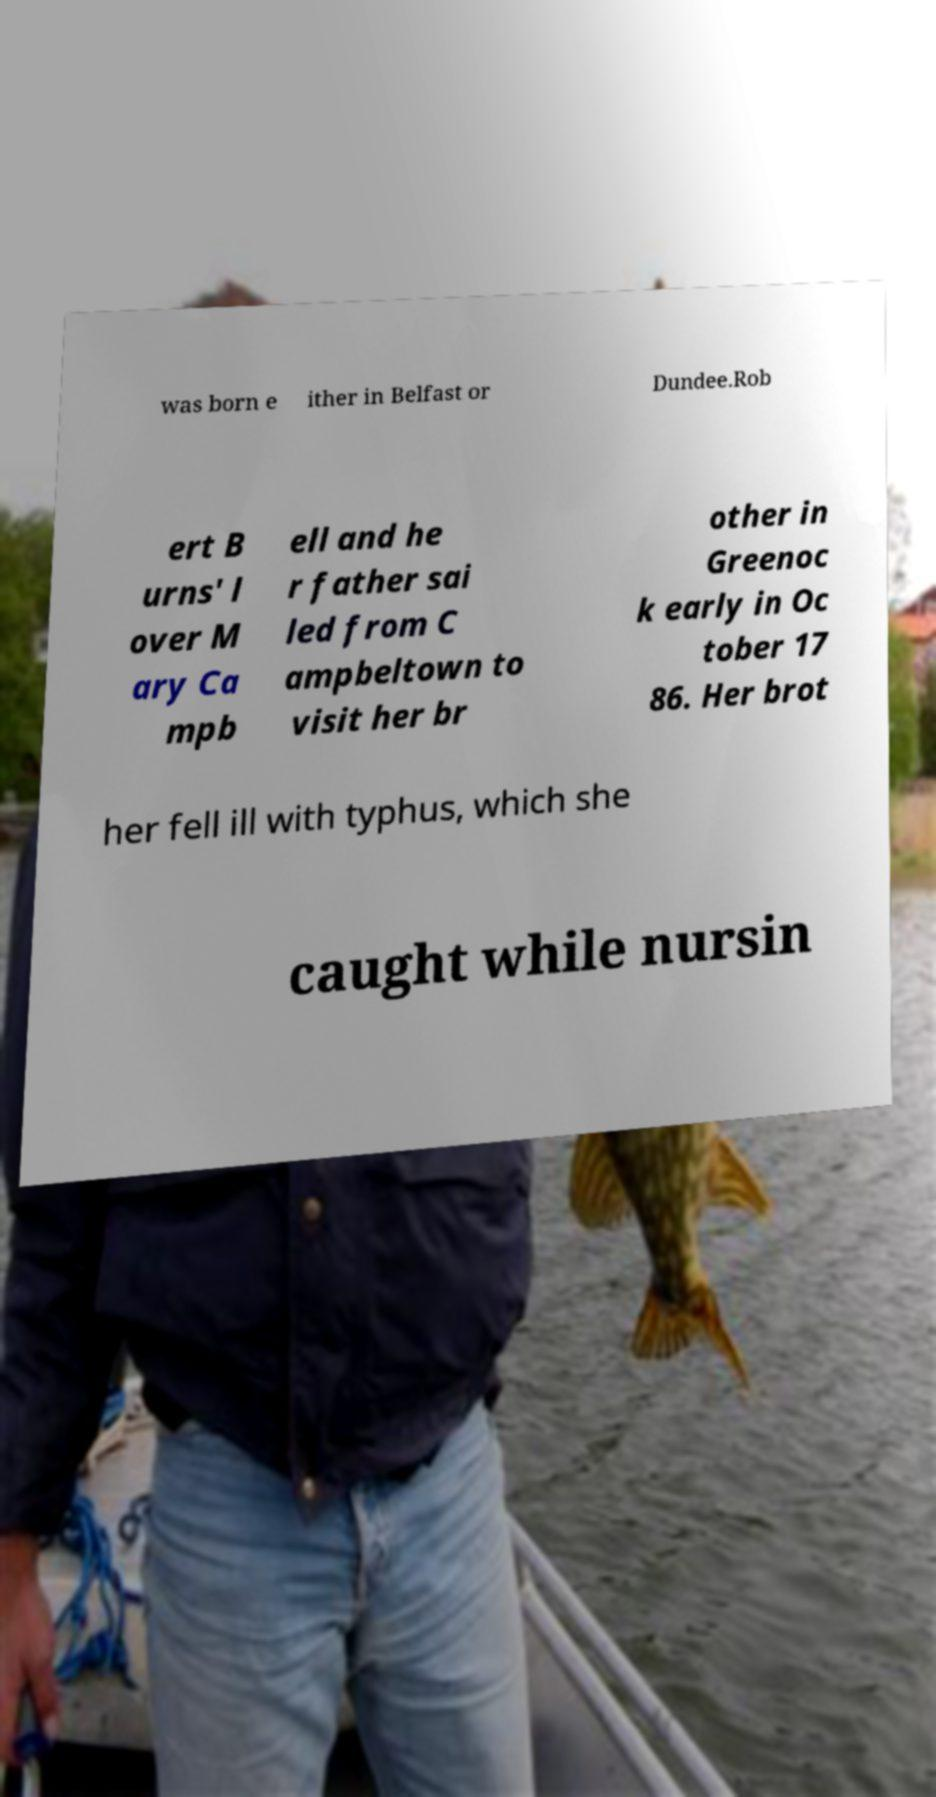Please identify and transcribe the text found in this image. was born e ither in Belfast or Dundee.Rob ert B urns' l over M ary Ca mpb ell and he r father sai led from C ampbeltown to visit her br other in Greenoc k early in Oc tober 17 86. Her brot her fell ill with typhus, which she caught while nursin 